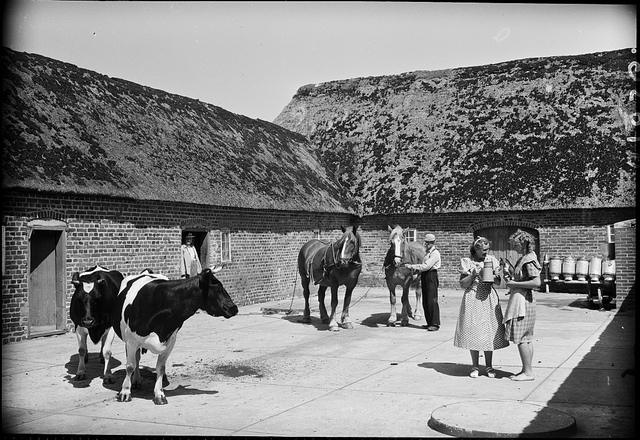<image>What is the house's foundation made of? I don't know exactly what the house's foundation is made of. It can be brick, concrete, cement or dirt. What is the house's foundation made of? I am not sure what the house's foundation is made of. It can be either brick or concrete. 